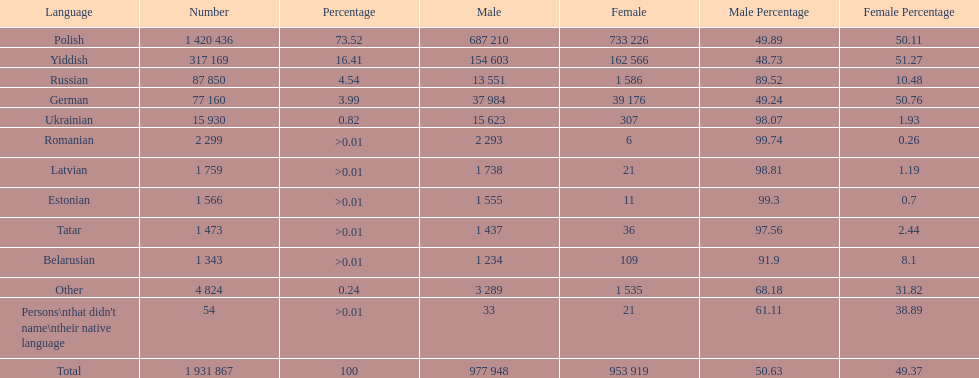What are the languages of the warsaw governorate? Polish, Yiddish, Russian, German, Ukrainian, Romanian, Latvian, Estonian, Tatar, Belarusian, Other. What is the percentage of polish? 73.52. Write the full table. {'header': ['Language', 'Number', 'Percentage', 'Male', 'Female', 'Male Percentage', 'Female Percentage'], 'rows': [['Polish', '1 420 436', '73.52', '687 210', '733 226', '49.89', '50.11'], ['Yiddish', '317 169', '16.41', '154 603', '162 566', '48.73', '51.27'], ['Russian', '87 850', '4.54', '13 551', '1 586', '89.52', '10.48'], ['German', '77 160', '3.99', '37 984', '39 176', '49.24', '50.76'], ['Ukrainian', '15 930', '0.82', '15 623', '307', '98.07', '1.93'], ['Romanian', '2 299', '>0.01', '2 293', '6', '99.74', '0.26'], ['Latvian', '1 759', '>0.01', '1 738', '21', '98.81', '1.19'], ['Estonian', '1 566', '>0.01', '1 555', '11', '99.3', '0.7'], ['Tatar', '1 473', '>0.01', '1 437', '36', '97.56', '2.44'], ['Belarusian', '1 343', '>0.01', '1 234', '109', '91.9', '8.1'], ['Other', '4 824', '0.24', '3 289', '1 535', '68.18', '31.82'], ["Persons\\nthat didn't name\\ntheir native language", '54', '>0.01', '33', '21', '61.11', '38.89'], ['Total', '1 931 867', '100', '977 948', '953 919', '50.63', '49.37']]} What is the next highest amount? 16.41. What is the language with this amount? Yiddish. 